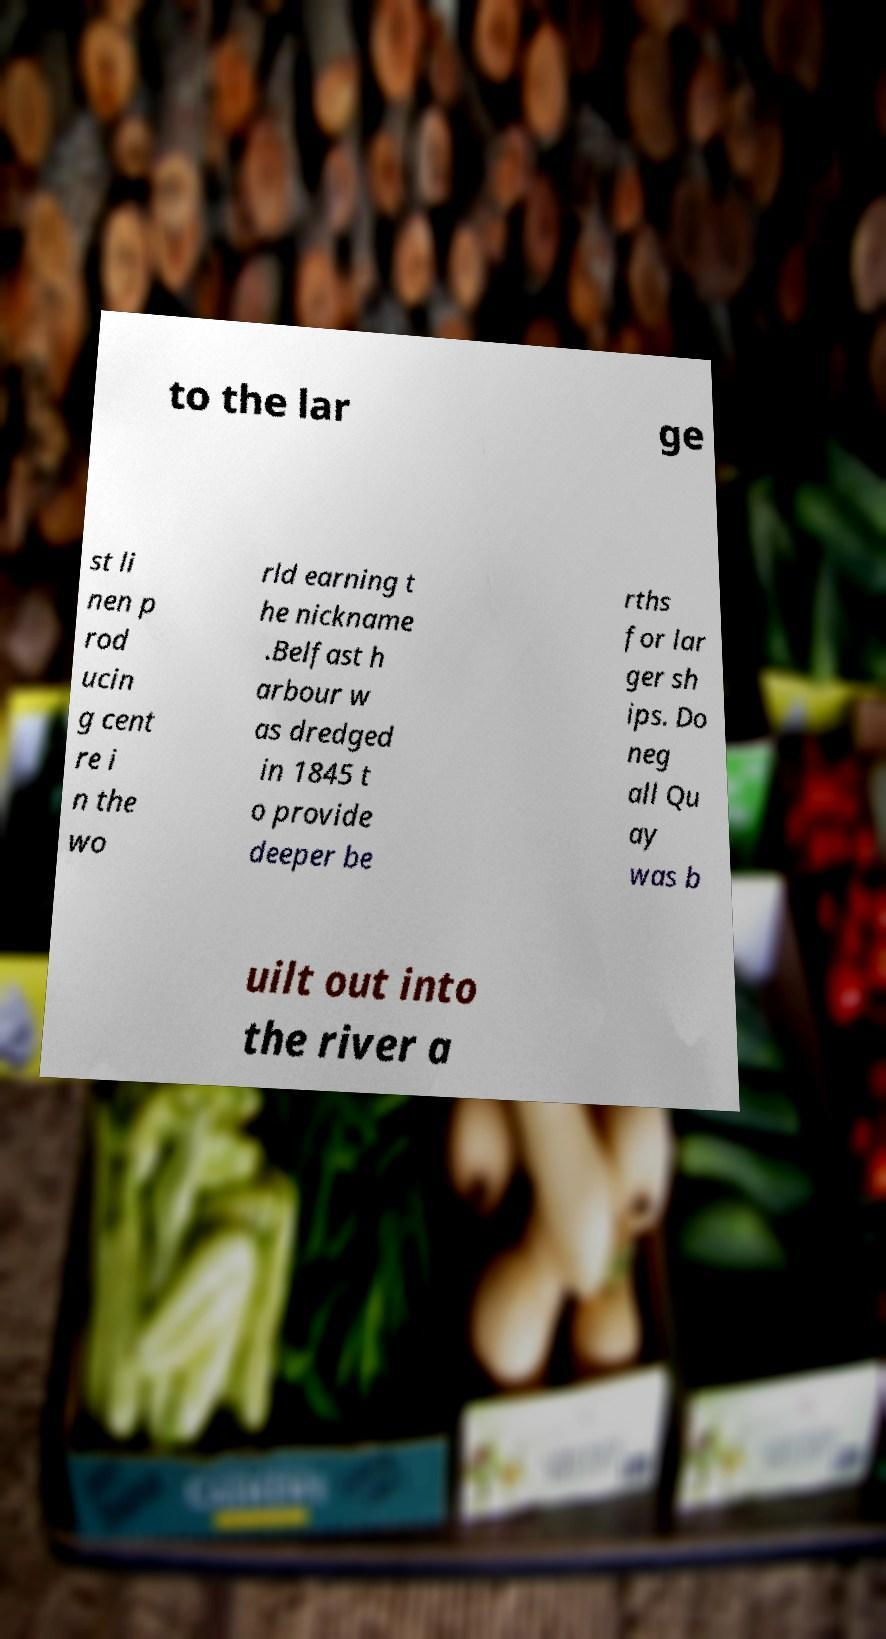Can you accurately transcribe the text from the provided image for me? to the lar ge st li nen p rod ucin g cent re i n the wo rld earning t he nickname .Belfast h arbour w as dredged in 1845 t o provide deeper be rths for lar ger sh ips. Do neg all Qu ay was b uilt out into the river a 